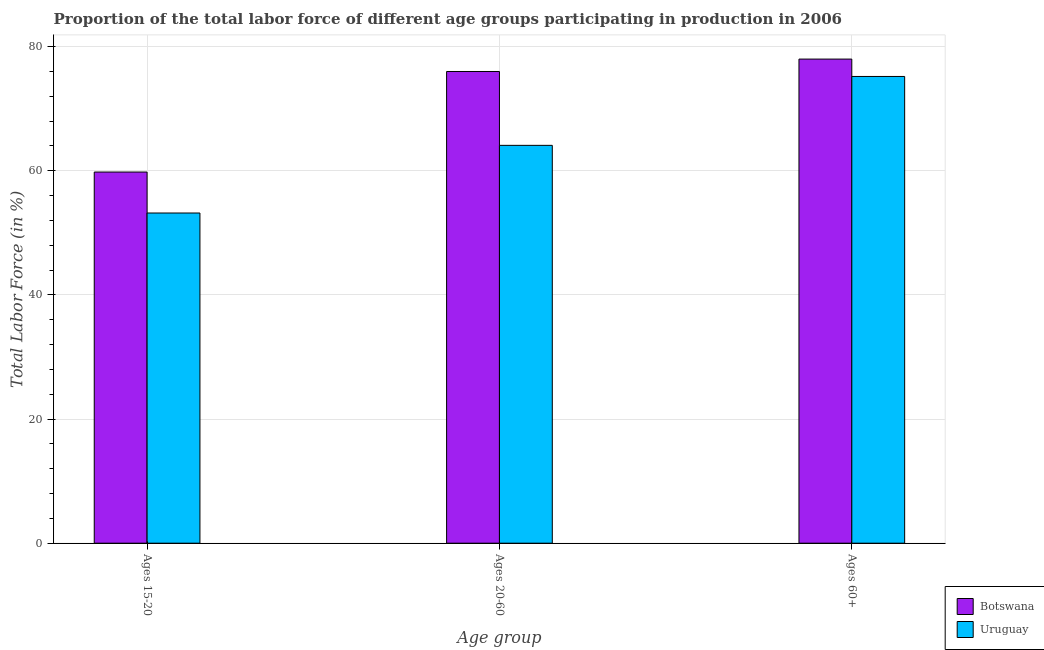How many different coloured bars are there?
Give a very brief answer. 2. How many groups of bars are there?
Ensure brevity in your answer.  3. How many bars are there on the 1st tick from the left?
Your answer should be very brief. 2. How many bars are there on the 3rd tick from the right?
Provide a short and direct response. 2. What is the label of the 2nd group of bars from the left?
Provide a short and direct response. Ages 20-60. What is the percentage of labor force above age 60 in Uruguay?
Your response must be concise. 75.2. Across all countries, what is the maximum percentage of labor force within the age group 15-20?
Provide a short and direct response. 59.8. Across all countries, what is the minimum percentage of labor force within the age group 20-60?
Provide a succinct answer. 64.1. In which country was the percentage of labor force within the age group 15-20 maximum?
Your answer should be very brief. Botswana. In which country was the percentage of labor force within the age group 15-20 minimum?
Keep it short and to the point. Uruguay. What is the total percentage of labor force within the age group 15-20 in the graph?
Your answer should be very brief. 113. What is the difference between the percentage of labor force within the age group 20-60 in Uruguay and that in Botswana?
Ensure brevity in your answer.  -11.9. What is the difference between the percentage of labor force within the age group 15-20 in Uruguay and the percentage of labor force above age 60 in Botswana?
Keep it short and to the point. -24.8. What is the average percentage of labor force above age 60 per country?
Offer a very short reply. 76.6. What is the difference between the percentage of labor force above age 60 and percentage of labor force within the age group 20-60 in Uruguay?
Your response must be concise. 11.1. What is the ratio of the percentage of labor force above age 60 in Botswana to that in Uruguay?
Give a very brief answer. 1.04. Is the difference between the percentage of labor force within the age group 20-60 in Uruguay and Botswana greater than the difference between the percentage of labor force above age 60 in Uruguay and Botswana?
Your response must be concise. No. What is the difference between the highest and the second highest percentage of labor force within the age group 15-20?
Provide a short and direct response. 6.6. What is the difference between the highest and the lowest percentage of labor force above age 60?
Provide a succinct answer. 2.8. What does the 1st bar from the left in Ages 15-20 represents?
Your answer should be very brief. Botswana. What does the 1st bar from the right in Ages 15-20 represents?
Provide a succinct answer. Uruguay. How many bars are there?
Offer a terse response. 6. Are all the bars in the graph horizontal?
Make the answer very short. No. What is the difference between two consecutive major ticks on the Y-axis?
Your response must be concise. 20. How are the legend labels stacked?
Your answer should be compact. Vertical. What is the title of the graph?
Offer a terse response. Proportion of the total labor force of different age groups participating in production in 2006. What is the label or title of the X-axis?
Give a very brief answer. Age group. What is the Total Labor Force (in %) of Botswana in Ages 15-20?
Keep it short and to the point. 59.8. What is the Total Labor Force (in %) in Uruguay in Ages 15-20?
Make the answer very short. 53.2. What is the Total Labor Force (in %) of Uruguay in Ages 20-60?
Offer a terse response. 64.1. What is the Total Labor Force (in %) in Uruguay in Ages 60+?
Provide a succinct answer. 75.2. Across all Age group, what is the maximum Total Labor Force (in %) in Botswana?
Make the answer very short. 78. Across all Age group, what is the maximum Total Labor Force (in %) of Uruguay?
Keep it short and to the point. 75.2. Across all Age group, what is the minimum Total Labor Force (in %) of Botswana?
Provide a short and direct response. 59.8. Across all Age group, what is the minimum Total Labor Force (in %) of Uruguay?
Make the answer very short. 53.2. What is the total Total Labor Force (in %) of Botswana in the graph?
Give a very brief answer. 213.8. What is the total Total Labor Force (in %) in Uruguay in the graph?
Offer a terse response. 192.5. What is the difference between the Total Labor Force (in %) of Botswana in Ages 15-20 and that in Ages 20-60?
Provide a succinct answer. -16.2. What is the difference between the Total Labor Force (in %) of Uruguay in Ages 15-20 and that in Ages 20-60?
Give a very brief answer. -10.9. What is the difference between the Total Labor Force (in %) in Botswana in Ages 15-20 and that in Ages 60+?
Offer a very short reply. -18.2. What is the difference between the Total Labor Force (in %) in Botswana in Ages 20-60 and that in Ages 60+?
Provide a succinct answer. -2. What is the difference between the Total Labor Force (in %) of Botswana in Ages 15-20 and the Total Labor Force (in %) of Uruguay in Ages 20-60?
Provide a short and direct response. -4.3. What is the difference between the Total Labor Force (in %) of Botswana in Ages 15-20 and the Total Labor Force (in %) of Uruguay in Ages 60+?
Offer a very short reply. -15.4. What is the difference between the Total Labor Force (in %) of Botswana in Ages 20-60 and the Total Labor Force (in %) of Uruguay in Ages 60+?
Make the answer very short. 0.8. What is the average Total Labor Force (in %) in Botswana per Age group?
Give a very brief answer. 71.27. What is the average Total Labor Force (in %) in Uruguay per Age group?
Provide a succinct answer. 64.17. What is the difference between the Total Labor Force (in %) of Botswana and Total Labor Force (in %) of Uruguay in Ages 60+?
Give a very brief answer. 2.8. What is the ratio of the Total Labor Force (in %) in Botswana in Ages 15-20 to that in Ages 20-60?
Provide a short and direct response. 0.79. What is the ratio of the Total Labor Force (in %) in Uruguay in Ages 15-20 to that in Ages 20-60?
Your response must be concise. 0.83. What is the ratio of the Total Labor Force (in %) of Botswana in Ages 15-20 to that in Ages 60+?
Your answer should be very brief. 0.77. What is the ratio of the Total Labor Force (in %) in Uruguay in Ages 15-20 to that in Ages 60+?
Provide a short and direct response. 0.71. What is the ratio of the Total Labor Force (in %) in Botswana in Ages 20-60 to that in Ages 60+?
Offer a terse response. 0.97. What is the ratio of the Total Labor Force (in %) in Uruguay in Ages 20-60 to that in Ages 60+?
Your answer should be compact. 0.85. 